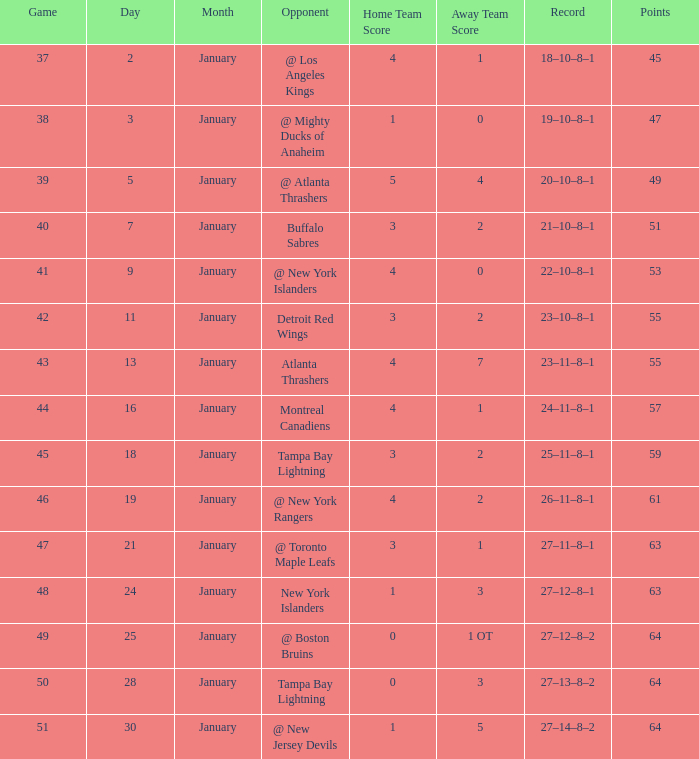How many games possess a score of 5-4, and points less than 49? 0.0. 